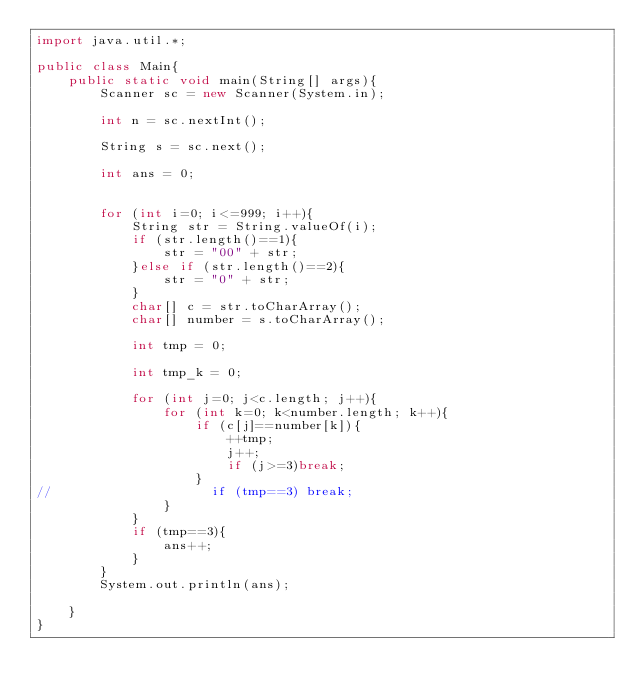Convert code to text. <code><loc_0><loc_0><loc_500><loc_500><_Java_>import java.util.*;

public class Main{
    public static void main(String[] args){
        Scanner sc = new Scanner(System.in);

        int n = sc.nextInt();

        String s = sc.next();

        int ans = 0;


        for (int i=0; i<=999; i++){
            String str = String.valueOf(i);
            if (str.length()==1){
                str = "00" + str;
            }else if (str.length()==2){
                str = "0" + str;
            }
            char[] c = str.toCharArray();
            char[] number = s.toCharArray();

            int tmp = 0;

            int tmp_k = 0;

            for (int j=0; j<c.length; j++){
                for (int k=0; k<number.length; k++){
                    if (c[j]==number[k]){
                        ++tmp;
                        j++;
                        if (j>=3)break;
                    }
//                    if (tmp==3) break;
                }
            }
            if (tmp==3){
                ans++;
            }
        }
        System.out.println(ans);

    }
}</code> 